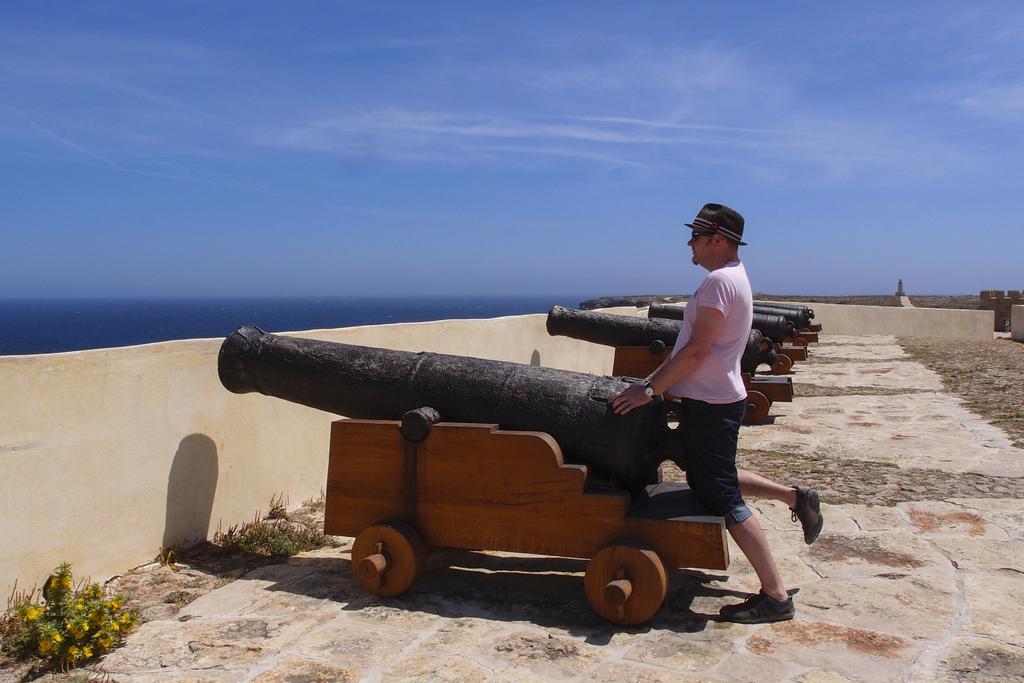Could you give a brief overview of what you see in this image? This image consists of a man wearing white T-shirt and a black hat. At the bottom, there is a floor. To the left, there is a wall. At the top, there is a sky. 